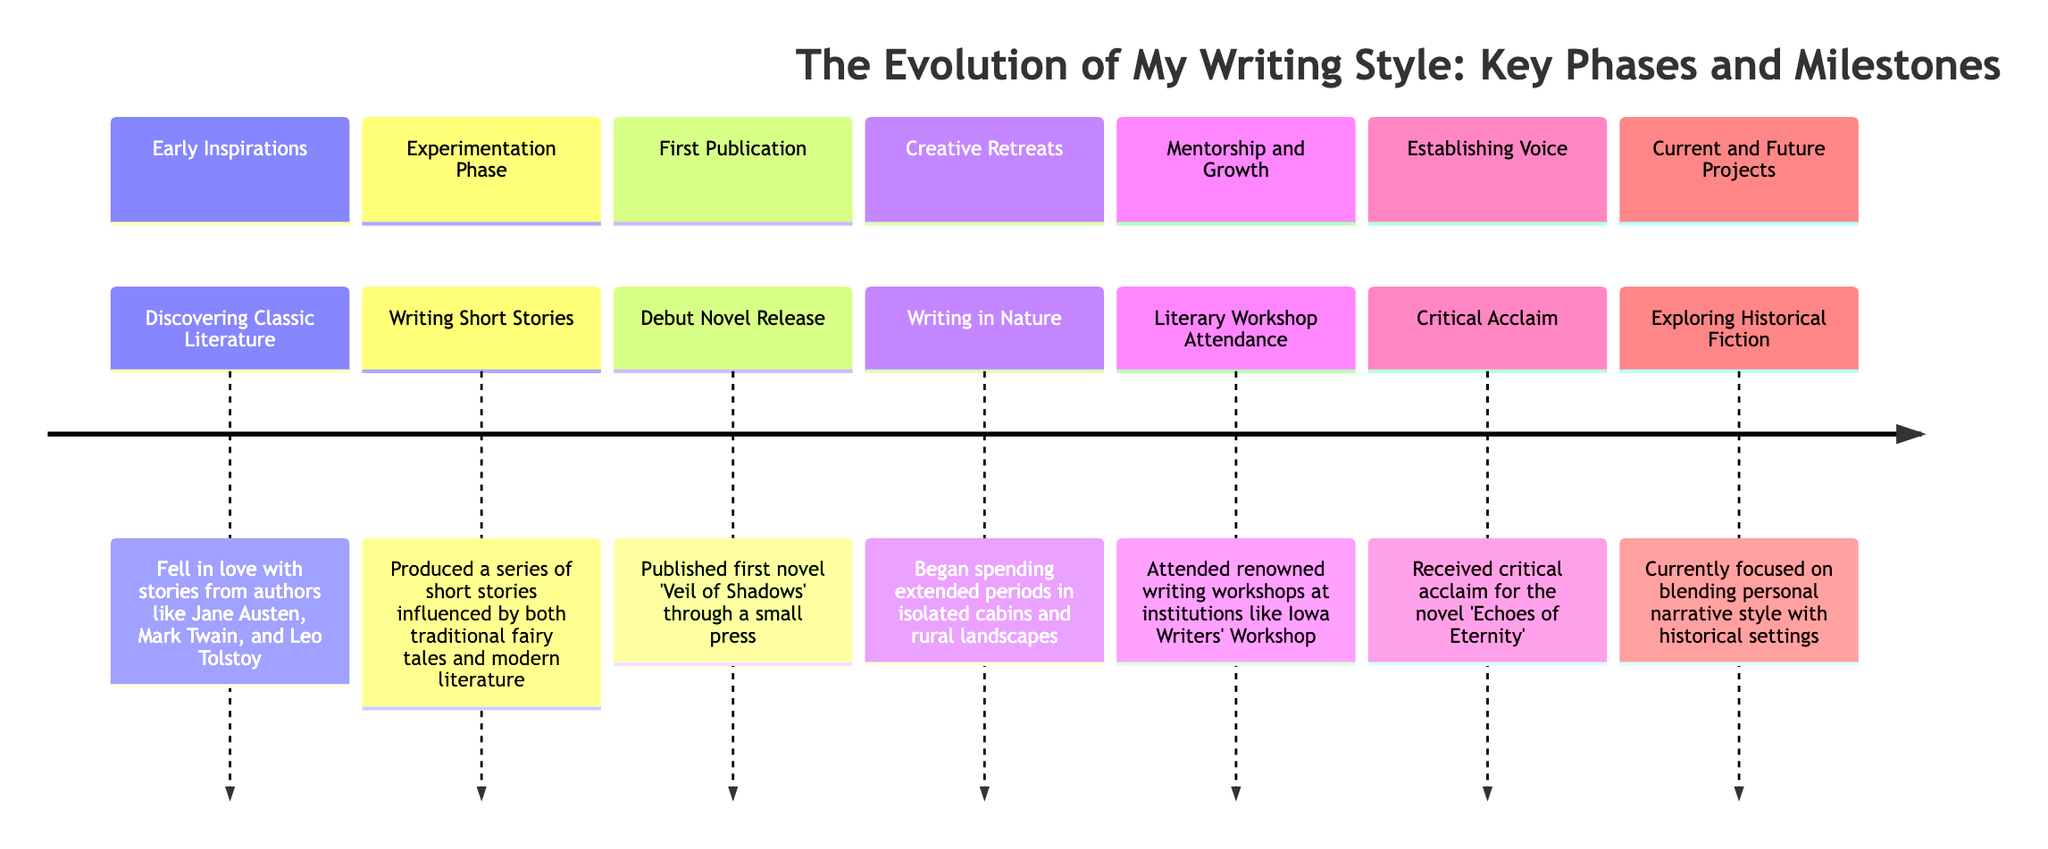What is the first milestone in the timeline? The first milestone listed in the timeline is "Discovering Classic Literature," which occurs in the phase "Early Inspirations."
Answer: Discovering Classic Literature How many phases are there in the timeline? There are a total of 7 phases presented in the timeline, each representing a significant development in the writing journey.
Answer: 7 What milestone is associated with the phase "Creative Retreats"? The milestone for the phase "Creative Retreats" is "Writing in Nature." This indicates the focus on finding inspiration in natural surroundings.
Answer: Writing in Nature Which milestone marks the transition from hobby to serious vocation? The milestone that signifies the transition from hobby writing to a serious vocation is the "Debut Novel Release." This reflects a critical step in the author's career.
Answer: Debut Novel Release What has the author currently focused on in their writing? The author is currently focused on "Exploring Historical Fiction," incorporating personal narrative style with historical settings.
Answer: Exploring Historical Fiction Which novel received critical acclaim? The novel "Echoes of Eternity" is the one that received critical acclaim, establishing the author's unique narrative voice.
Answer: Echoes of Eternity In which phase did the author attend literary workshops? The author attended literary workshops during the phase titled "Mentorship and Growth," which was crucial for obtaining feedback and refining their writing style.
Answer: Mentorship and Growth What type of writing was produced during the "Experimentation Phase"? During the "Experimentation Phase," the author produced "Short Stories," exploring various genres and writing techniques.
Answer: Short Stories What publicly available press published the author's debut novel? The author's debut novel "Veil of Shadows" was published through a "small press," indicating a more intimate publishing experience.
Answer: small press 